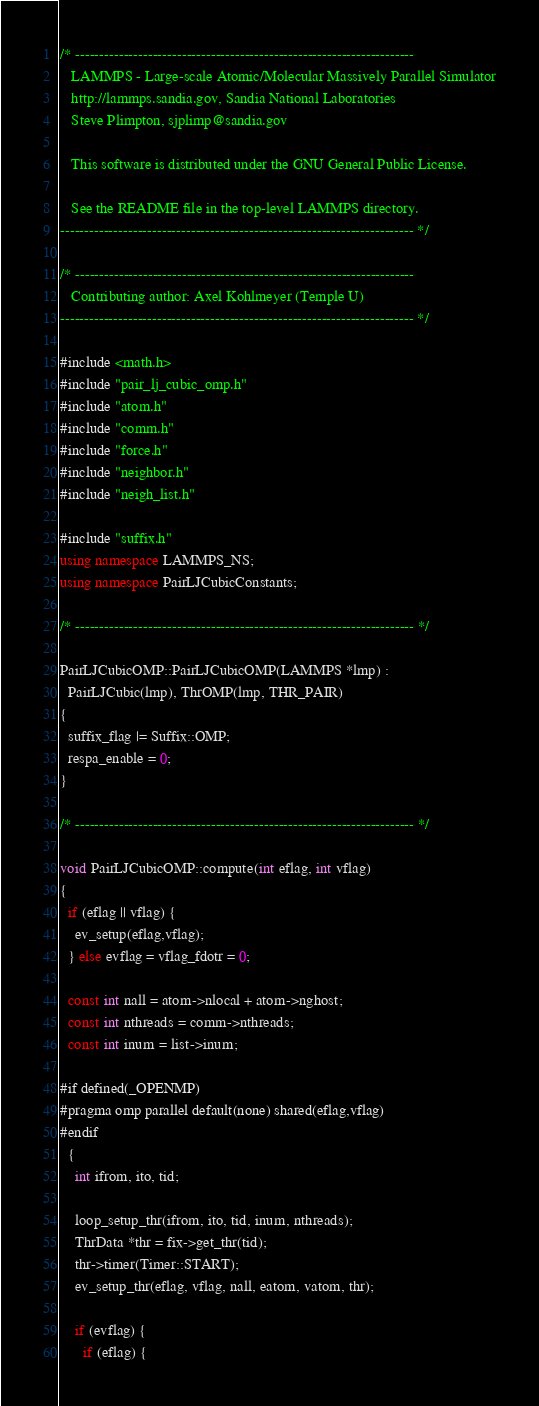<code> <loc_0><loc_0><loc_500><loc_500><_C++_>/* ----------------------------------------------------------------------
   LAMMPS - Large-scale Atomic/Molecular Massively Parallel Simulator
   http://lammps.sandia.gov, Sandia National Laboratories
   Steve Plimpton, sjplimp@sandia.gov

   This software is distributed under the GNU General Public License.

   See the README file in the top-level LAMMPS directory.
------------------------------------------------------------------------- */

/* ----------------------------------------------------------------------
   Contributing author: Axel Kohlmeyer (Temple U)
------------------------------------------------------------------------- */

#include <math.h>
#include "pair_lj_cubic_omp.h"
#include "atom.h"
#include "comm.h"
#include "force.h"
#include "neighbor.h"
#include "neigh_list.h"

#include "suffix.h"
using namespace LAMMPS_NS;
using namespace PairLJCubicConstants;

/* ---------------------------------------------------------------------- */

PairLJCubicOMP::PairLJCubicOMP(LAMMPS *lmp) :
  PairLJCubic(lmp), ThrOMP(lmp, THR_PAIR)
{
  suffix_flag |= Suffix::OMP;
  respa_enable = 0;
}

/* ---------------------------------------------------------------------- */

void PairLJCubicOMP::compute(int eflag, int vflag)
{
  if (eflag || vflag) {
    ev_setup(eflag,vflag);
  } else evflag = vflag_fdotr = 0;

  const int nall = atom->nlocal + atom->nghost;
  const int nthreads = comm->nthreads;
  const int inum = list->inum;

#if defined(_OPENMP)
#pragma omp parallel default(none) shared(eflag,vflag)
#endif
  {
    int ifrom, ito, tid;

    loop_setup_thr(ifrom, ito, tid, inum, nthreads);
    ThrData *thr = fix->get_thr(tid);
    thr->timer(Timer::START);
    ev_setup_thr(eflag, vflag, nall, eatom, vatom, thr);

    if (evflag) {
      if (eflag) {</code> 